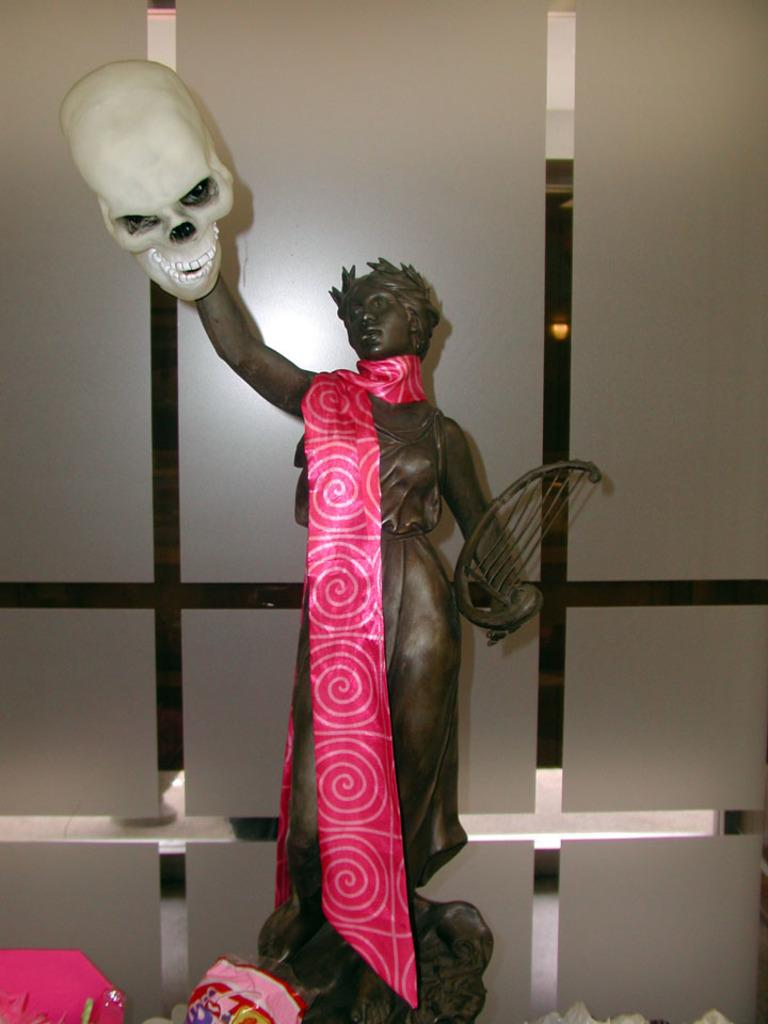What is the main subject in the image? There is a sculpture in the image. Can you describe the setting of the sculpture? The sculpture is in front of a glass wall. What type of peace is being promoted by the judge and friends in the image? There is no judge or friends present in the image, and therefore no such activity or promotion can be observed. 